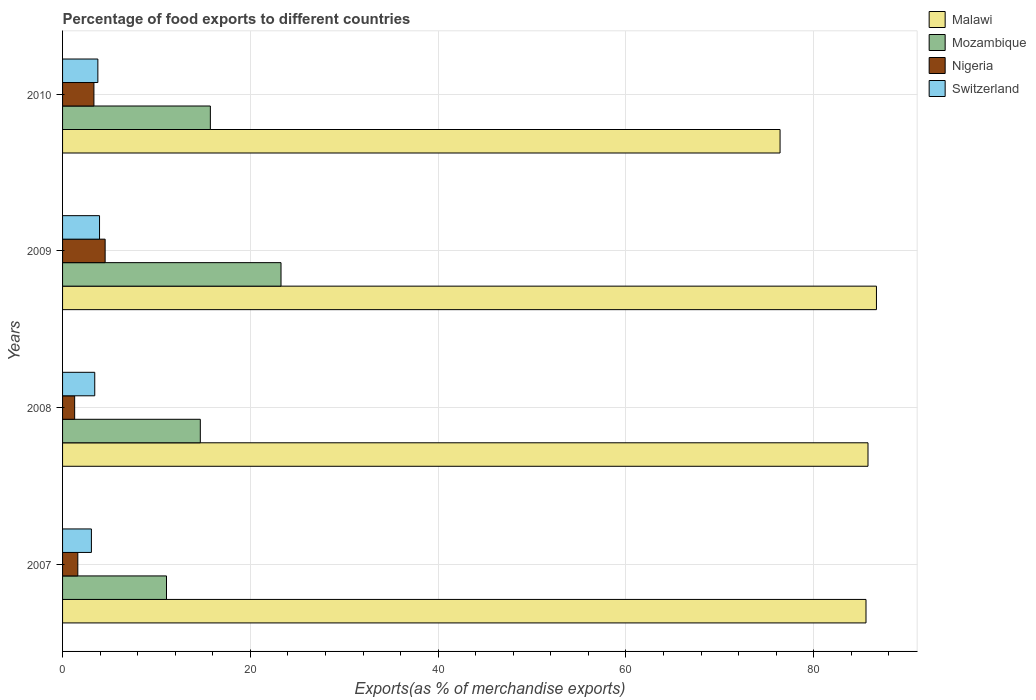Are the number of bars on each tick of the Y-axis equal?
Your answer should be compact. Yes. What is the label of the 1st group of bars from the top?
Provide a short and direct response. 2010. What is the percentage of exports to different countries in Nigeria in 2007?
Offer a very short reply. 1.62. Across all years, what is the maximum percentage of exports to different countries in Nigeria?
Give a very brief answer. 4.53. Across all years, what is the minimum percentage of exports to different countries in Switzerland?
Offer a very short reply. 3.07. In which year was the percentage of exports to different countries in Switzerland maximum?
Make the answer very short. 2009. In which year was the percentage of exports to different countries in Mozambique minimum?
Your answer should be compact. 2007. What is the total percentage of exports to different countries in Nigeria in the graph?
Keep it short and to the point. 10.78. What is the difference between the percentage of exports to different countries in Switzerland in 2009 and that in 2010?
Keep it short and to the point. 0.18. What is the difference between the percentage of exports to different countries in Nigeria in 2009 and the percentage of exports to different countries in Switzerland in 2008?
Your answer should be very brief. 1.11. What is the average percentage of exports to different countries in Switzerland per year?
Offer a terse response. 3.55. In the year 2007, what is the difference between the percentage of exports to different countries in Mozambique and percentage of exports to different countries in Malawi?
Your answer should be compact. -74.5. What is the ratio of the percentage of exports to different countries in Malawi in 2007 to that in 2008?
Your response must be concise. 1. What is the difference between the highest and the second highest percentage of exports to different countries in Switzerland?
Offer a very short reply. 0.18. What is the difference between the highest and the lowest percentage of exports to different countries in Nigeria?
Keep it short and to the point. 3.25. What does the 2nd bar from the top in 2008 represents?
Provide a short and direct response. Nigeria. What does the 3rd bar from the bottom in 2010 represents?
Give a very brief answer. Nigeria. Is it the case that in every year, the sum of the percentage of exports to different countries in Mozambique and percentage of exports to different countries in Nigeria is greater than the percentage of exports to different countries in Malawi?
Ensure brevity in your answer.  No. What is the difference between two consecutive major ticks on the X-axis?
Ensure brevity in your answer.  20. Does the graph contain grids?
Your answer should be very brief. Yes. Where does the legend appear in the graph?
Provide a short and direct response. Top right. What is the title of the graph?
Ensure brevity in your answer.  Percentage of food exports to different countries. What is the label or title of the X-axis?
Ensure brevity in your answer.  Exports(as % of merchandise exports). What is the label or title of the Y-axis?
Your response must be concise. Years. What is the Exports(as % of merchandise exports) of Malawi in 2007?
Provide a succinct answer. 85.57. What is the Exports(as % of merchandise exports) of Mozambique in 2007?
Offer a very short reply. 11.07. What is the Exports(as % of merchandise exports) in Nigeria in 2007?
Your response must be concise. 1.62. What is the Exports(as % of merchandise exports) of Switzerland in 2007?
Provide a short and direct response. 3.07. What is the Exports(as % of merchandise exports) in Malawi in 2008?
Your response must be concise. 85.79. What is the Exports(as % of merchandise exports) in Mozambique in 2008?
Provide a short and direct response. 14.67. What is the Exports(as % of merchandise exports) in Nigeria in 2008?
Ensure brevity in your answer.  1.29. What is the Exports(as % of merchandise exports) of Switzerland in 2008?
Your response must be concise. 3.43. What is the Exports(as % of merchandise exports) of Malawi in 2009?
Ensure brevity in your answer.  86.69. What is the Exports(as % of merchandise exports) of Mozambique in 2009?
Your answer should be very brief. 23.27. What is the Exports(as % of merchandise exports) in Nigeria in 2009?
Your answer should be very brief. 4.53. What is the Exports(as % of merchandise exports) of Switzerland in 2009?
Your answer should be very brief. 3.94. What is the Exports(as % of merchandise exports) of Malawi in 2010?
Keep it short and to the point. 76.42. What is the Exports(as % of merchandise exports) in Mozambique in 2010?
Keep it short and to the point. 15.74. What is the Exports(as % of merchandise exports) of Nigeria in 2010?
Offer a very short reply. 3.34. What is the Exports(as % of merchandise exports) in Switzerland in 2010?
Your response must be concise. 3.76. Across all years, what is the maximum Exports(as % of merchandise exports) of Malawi?
Keep it short and to the point. 86.69. Across all years, what is the maximum Exports(as % of merchandise exports) in Mozambique?
Provide a short and direct response. 23.27. Across all years, what is the maximum Exports(as % of merchandise exports) in Nigeria?
Your response must be concise. 4.53. Across all years, what is the maximum Exports(as % of merchandise exports) in Switzerland?
Offer a very short reply. 3.94. Across all years, what is the minimum Exports(as % of merchandise exports) in Malawi?
Make the answer very short. 76.42. Across all years, what is the minimum Exports(as % of merchandise exports) in Mozambique?
Keep it short and to the point. 11.07. Across all years, what is the minimum Exports(as % of merchandise exports) of Nigeria?
Offer a very short reply. 1.29. Across all years, what is the minimum Exports(as % of merchandise exports) in Switzerland?
Ensure brevity in your answer.  3.07. What is the total Exports(as % of merchandise exports) in Malawi in the graph?
Your answer should be compact. 334.46. What is the total Exports(as % of merchandise exports) of Mozambique in the graph?
Your answer should be very brief. 64.75. What is the total Exports(as % of merchandise exports) of Nigeria in the graph?
Ensure brevity in your answer.  10.78. What is the total Exports(as % of merchandise exports) in Switzerland in the graph?
Your answer should be compact. 14.19. What is the difference between the Exports(as % of merchandise exports) in Malawi in 2007 and that in 2008?
Offer a terse response. -0.21. What is the difference between the Exports(as % of merchandise exports) of Mozambique in 2007 and that in 2008?
Offer a terse response. -3.6. What is the difference between the Exports(as % of merchandise exports) in Nigeria in 2007 and that in 2008?
Offer a very short reply. 0.34. What is the difference between the Exports(as % of merchandise exports) of Switzerland in 2007 and that in 2008?
Keep it short and to the point. -0.36. What is the difference between the Exports(as % of merchandise exports) in Malawi in 2007 and that in 2009?
Provide a succinct answer. -1.11. What is the difference between the Exports(as % of merchandise exports) of Mozambique in 2007 and that in 2009?
Ensure brevity in your answer.  -12.2. What is the difference between the Exports(as % of merchandise exports) in Nigeria in 2007 and that in 2009?
Make the answer very short. -2.91. What is the difference between the Exports(as % of merchandise exports) in Switzerland in 2007 and that in 2009?
Give a very brief answer. -0.87. What is the difference between the Exports(as % of merchandise exports) of Malawi in 2007 and that in 2010?
Your answer should be compact. 9.15. What is the difference between the Exports(as % of merchandise exports) of Mozambique in 2007 and that in 2010?
Your answer should be compact. -4.67. What is the difference between the Exports(as % of merchandise exports) in Nigeria in 2007 and that in 2010?
Ensure brevity in your answer.  -1.72. What is the difference between the Exports(as % of merchandise exports) in Switzerland in 2007 and that in 2010?
Offer a terse response. -0.69. What is the difference between the Exports(as % of merchandise exports) in Malawi in 2008 and that in 2009?
Ensure brevity in your answer.  -0.9. What is the difference between the Exports(as % of merchandise exports) in Mozambique in 2008 and that in 2009?
Ensure brevity in your answer.  -8.6. What is the difference between the Exports(as % of merchandise exports) of Nigeria in 2008 and that in 2009?
Make the answer very short. -3.25. What is the difference between the Exports(as % of merchandise exports) of Switzerland in 2008 and that in 2009?
Offer a very short reply. -0.51. What is the difference between the Exports(as % of merchandise exports) in Malawi in 2008 and that in 2010?
Your response must be concise. 9.37. What is the difference between the Exports(as % of merchandise exports) of Mozambique in 2008 and that in 2010?
Your answer should be compact. -1.07. What is the difference between the Exports(as % of merchandise exports) of Nigeria in 2008 and that in 2010?
Provide a short and direct response. -2.05. What is the difference between the Exports(as % of merchandise exports) of Switzerland in 2008 and that in 2010?
Your answer should be compact. -0.33. What is the difference between the Exports(as % of merchandise exports) of Malawi in 2009 and that in 2010?
Your answer should be compact. 10.27. What is the difference between the Exports(as % of merchandise exports) of Mozambique in 2009 and that in 2010?
Ensure brevity in your answer.  7.53. What is the difference between the Exports(as % of merchandise exports) of Nigeria in 2009 and that in 2010?
Offer a terse response. 1.19. What is the difference between the Exports(as % of merchandise exports) of Switzerland in 2009 and that in 2010?
Offer a very short reply. 0.18. What is the difference between the Exports(as % of merchandise exports) of Malawi in 2007 and the Exports(as % of merchandise exports) of Mozambique in 2008?
Your answer should be compact. 70.9. What is the difference between the Exports(as % of merchandise exports) of Malawi in 2007 and the Exports(as % of merchandise exports) of Nigeria in 2008?
Keep it short and to the point. 84.28. What is the difference between the Exports(as % of merchandise exports) in Malawi in 2007 and the Exports(as % of merchandise exports) in Switzerland in 2008?
Give a very brief answer. 82.14. What is the difference between the Exports(as % of merchandise exports) in Mozambique in 2007 and the Exports(as % of merchandise exports) in Nigeria in 2008?
Keep it short and to the point. 9.78. What is the difference between the Exports(as % of merchandise exports) in Mozambique in 2007 and the Exports(as % of merchandise exports) in Switzerland in 2008?
Your answer should be compact. 7.64. What is the difference between the Exports(as % of merchandise exports) of Nigeria in 2007 and the Exports(as % of merchandise exports) of Switzerland in 2008?
Keep it short and to the point. -1.8. What is the difference between the Exports(as % of merchandise exports) in Malawi in 2007 and the Exports(as % of merchandise exports) in Mozambique in 2009?
Ensure brevity in your answer.  62.31. What is the difference between the Exports(as % of merchandise exports) of Malawi in 2007 and the Exports(as % of merchandise exports) of Nigeria in 2009?
Give a very brief answer. 81.04. What is the difference between the Exports(as % of merchandise exports) of Malawi in 2007 and the Exports(as % of merchandise exports) of Switzerland in 2009?
Your response must be concise. 81.63. What is the difference between the Exports(as % of merchandise exports) of Mozambique in 2007 and the Exports(as % of merchandise exports) of Nigeria in 2009?
Ensure brevity in your answer.  6.54. What is the difference between the Exports(as % of merchandise exports) in Mozambique in 2007 and the Exports(as % of merchandise exports) in Switzerland in 2009?
Provide a short and direct response. 7.13. What is the difference between the Exports(as % of merchandise exports) of Nigeria in 2007 and the Exports(as % of merchandise exports) of Switzerland in 2009?
Provide a short and direct response. -2.31. What is the difference between the Exports(as % of merchandise exports) of Malawi in 2007 and the Exports(as % of merchandise exports) of Mozambique in 2010?
Your answer should be compact. 69.83. What is the difference between the Exports(as % of merchandise exports) in Malawi in 2007 and the Exports(as % of merchandise exports) in Nigeria in 2010?
Ensure brevity in your answer.  82.23. What is the difference between the Exports(as % of merchandise exports) of Malawi in 2007 and the Exports(as % of merchandise exports) of Switzerland in 2010?
Give a very brief answer. 81.81. What is the difference between the Exports(as % of merchandise exports) in Mozambique in 2007 and the Exports(as % of merchandise exports) in Nigeria in 2010?
Make the answer very short. 7.73. What is the difference between the Exports(as % of merchandise exports) in Mozambique in 2007 and the Exports(as % of merchandise exports) in Switzerland in 2010?
Offer a very short reply. 7.31. What is the difference between the Exports(as % of merchandise exports) in Nigeria in 2007 and the Exports(as % of merchandise exports) in Switzerland in 2010?
Your answer should be very brief. -2.14. What is the difference between the Exports(as % of merchandise exports) of Malawi in 2008 and the Exports(as % of merchandise exports) of Mozambique in 2009?
Keep it short and to the point. 62.52. What is the difference between the Exports(as % of merchandise exports) of Malawi in 2008 and the Exports(as % of merchandise exports) of Nigeria in 2009?
Ensure brevity in your answer.  81.25. What is the difference between the Exports(as % of merchandise exports) in Malawi in 2008 and the Exports(as % of merchandise exports) in Switzerland in 2009?
Your answer should be very brief. 81.85. What is the difference between the Exports(as % of merchandise exports) of Mozambique in 2008 and the Exports(as % of merchandise exports) of Nigeria in 2009?
Keep it short and to the point. 10.14. What is the difference between the Exports(as % of merchandise exports) in Mozambique in 2008 and the Exports(as % of merchandise exports) in Switzerland in 2009?
Provide a succinct answer. 10.73. What is the difference between the Exports(as % of merchandise exports) in Nigeria in 2008 and the Exports(as % of merchandise exports) in Switzerland in 2009?
Offer a terse response. -2.65. What is the difference between the Exports(as % of merchandise exports) of Malawi in 2008 and the Exports(as % of merchandise exports) of Mozambique in 2010?
Give a very brief answer. 70.04. What is the difference between the Exports(as % of merchandise exports) of Malawi in 2008 and the Exports(as % of merchandise exports) of Nigeria in 2010?
Make the answer very short. 82.45. What is the difference between the Exports(as % of merchandise exports) in Malawi in 2008 and the Exports(as % of merchandise exports) in Switzerland in 2010?
Offer a very short reply. 82.03. What is the difference between the Exports(as % of merchandise exports) of Mozambique in 2008 and the Exports(as % of merchandise exports) of Nigeria in 2010?
Give a very brief answer. 11.33. What is the difference between the Exports(as % of merchandise exports) of Mozambique in 2008 and the Exports(as % of merchandise exports) of Switzerland in 2010?
Make the answer very short. 10.91. What is the difference between the Exports(as % of merchandise exports) of Nigeria in 2008 and the Exports(as % of merchandise exports) of Switzerland in 2010?
Ensure brevity in your answer.  -2.47. What is the difference between the Exports(as % of merchandise exports) in Malawi in 2009 and the Exports(as % of merchandise exports) in Mozambique in 2010?
Keep it short and to the point. 70.94. What is the difference between the Exports(as % of merchandise exports) in Malawi in 2009 and the Exports(as % of merchandise exports) in Nigeria in 2010?
Give a very brief answer. 83.35. What is the difference between the Exports(as % of merchandise exports) in Malawi in 2009 and the Exports(as % of merchandise exports) in Switzerland in 2010?
Provide a short and direct response. 82.93. What is the difference between the Exports(as % of merchandise exports) in Mozambique in 2009 and the Exports(as % of merchandise exports) in Nigeria in 2010?
Your answer should be very brief. 19.93. What is the difference between the Exports(as % of merchandise exports) in Mozambique in 2009 and the Exports(as % of merchandise exports) in Switzerland in 2010?
Ensure brevity in your answer.  19.51. What is the difference between the Exports(as % of merchandise exports) in Nigeria in 2009 and the Exports(as % of merchandise exports) in Switzerland in 2010?
Keep it short and to the point. 0.78. What is the average Exports(as % of merchandise exports) in Malawi per year?
Your answer should be very brief. 83.62. What is the average Exports(as % of merchandise exports) in Mozambique per year?
Offer a very short reply. 16.19. What is the average Exports(as % of merchandise exports) in Nigeria per year?
Provide a succinct answer. 2.7. What is the average Exports(as % of merchandise exports) in Switzerland per year?
Make the answer very short. 3.55. In the year 2007, what is the difference between the Exports(as % of merchandise exports) in Malawi and Exports(as % of merchandise exports) in Mozambique?
Provide a short and direct response. 74.5. In the year 2007, what is the difference between the Exports(as % of merchandise exports) in Malawi and Exports(as % of merchandise exports) in Nigeria?
Ensure brevity in your answer.  83.95. In the year 2007, what is the difference between the Exports(as % of merchandise exports) in Malawi and Exports(as % of merchandise exports) in Switzerland?
Your answer should be compact. 82.5. In the year 2007, what is the difference between the Exports(as % of merchandise exports) of Mozambique and Exports(as % of merchandise exports) of Nigeria?
Ensure brevity in your answer.  9.45. In the year 2007, what is the difference between the Exports(as % of merchandise exports) in Mozambique and Exports(as % of merchandise exports) in Switzerland?
Your answer should be compact. 8. In the year 2007, what is the difference between the Exports(as % of merchandise exports) of Nigeria and Exports(as % of merchandise exports) of Switzerland?
Your answer should be compact. -1.45. In the year 2008, what is the difference between the Exports(as % of merchandise exports) in Malawi and Exports(as % of merchandise exports) in Mozambique?
Ensure brevity in your answer.  71.12. In the year 2008, what is the difference between the Exports(as % of merchandise exports) in Malawi and Exports(as % of merchandise exports) in Nigeria?
Give a very brief answer. 84.5. In the year 2008, what is the difference between the Exports(as % of merchandise exports) of Malawi and Exports(as % of merchandise exports) of Switzerland?
Make the answer very short. 82.36. In the year 2008, what is the difference between the Exports(as % of merchandise exports) in Mozambique and Exports(as % of merchandise exports) in Nigeria?
Offer a terse response. 13.38. In the year 2008, what is the difference between the Exports(as % of merchandise exports) in Mozambique and Exports(as % of merchandise exports) in Switzerland?
Offer a terse response. 11.24. In the year 2008, what is the difference between the Exports(as % of merchandise exports) of Nigeria and Exports(as % of merchandise exports) of Switzerland?
Your response must be concise. -2.14. In the year 2009, what is the difference between the Exports(as % of merchandise exports) of Malawi and Exports(as % of merchandise exports) of Mozambique?
Ensure brevity in your answer.  63.42. In the year 2009, what is the difference between the Exports(as % of merchandise exports) in Malawi and Exports(as % of merchandise exports) in Nigeria?
Provide a short and direct response. 82.15. In the year 2009, what is the difference between the Exports(as % of merchandise exports) in Malawi and Exports(as % of merchandise exports) in Switzerland?
Provide a succinct answer. 82.75. In the year 2009, what is the difference between the Exports(as % of merchandise exports) in Mozambique and Exports(as % of merchandise exports) in Nigeria?
Ensure brevity in your answer.  18.73. In the year 2009, what is the difference between the Exports(as % of merchandise exports) in Mozambique and Exports(as % of merchandise exports) in Switzerland?
Offer a very short reply. 19.33. In the year 2009, what is the difference between the Exports(as % of merchandise exports) of Nigeria and Exports(as % of merchandise exports) of Switzerland?
Keep it short and to the point. 0.6. In the year 2010, what is the difference between the Exports(as % of merchandise exports) in Malawi and Exports(as % of merchandise exports) in Mozambique?
Keep it short and to the point. 60.68. In the year 2010, what is the difference between the Exports(as % of merchandise exports) in Malawi and Exports(as % of merchandise exports) in Nigeria?
Make the answer very short. 73.08. In the year 2010, what is the difference between the Exports(as % of merchandise exports) in Malawi and Exports(as % of merchandise exports) in Switzerland?
Your answer should be compact. 72.66. In the year 2010, what is the difference between the Exports(as % of merchandise exports) in Mozambique and Exports(as % of merchandise exports) in Nigeria?
Provide a succinct answer. 12.4. In the year 2010, what is the difference between the Exports(as % of merchandise exports) of Mozambique and Exports(as % of merchandise exports) of Switzerland?
Ensure brevity in your answer.  11.98. In the year 2010, what is the difference between the Exports(as % of merchandise exports) of Nigeria and Exports(as % of merchandise exports) of Switzerland?
Your answer should be very brief. -0.42. What is the ratio of the Exports(as % of merchandise exports) in Mozambique in 2007 to that in 2008?
Your response must be concise. 0.75. What is the ratio of the Exports(as % of merchandise exports) of Nigeria in 2007 to that in 2008?
Your answer should be very brief. 1.26. What is the ratio of the Exports(as % of merchandise exports) in Switzerland in 2007 to that in 2008?
Give a very brief answer. 0.9. What is the ratio of the Exports(as % of merchandise exports) of Malawi in 2007 to that in 2009?
Keep it short and to the point. 0.99. What is the ratio of the Exports(as % of merchandise exports) in Mozambique in 2007 to that in 2009?
Keep it short and to the point. 0.48. What is the ratio of the Exports(as % of merchandise exports) of Nigeria in 2007 to that in 2009?
Make the answer very short. 0.36. What is the ratio of the Exports(as % of merchandise exports) of Switzerland in 2007 to that in 2009?
Provide a succinct answer. 0.78. What is the ratio of the Exports(as % of merchandise exports) of Malawi in 2007 to that in 2010?
Offer a very short reply. 1.12. What is the ratio of the Exports(as % of merchandise exports) in Mozambique in 2007 to that in 2010?
Give a very brief answer. 0.7. What is the ratio of the Exports(as % of merchandise exports) in Nigeria in 2007 to that in 2010?
Offer a very short reply. 0.49. What is the ratio of the Exports(as % of merchandise exports) in Switzerland in 2007 to that in 2010?
Give a very brief answer. 0.82. What is the ratio of the Exports(as % of merchandise exports) in Malawi in 2008 to that in 2009?
Offer a very short reply. 0.99. What is the ratio of the Exports(as % of merchandise exports) in Mozambique in 2008 to that in 2009?
Provide a short and direct response. 0.63. What is the ratio of the Exports(as % of merchandise exports) of Nigeria in 2008 to that in 2009?
Your response must be concise. 0.28. What is the ratio of the Exports(as % of merchandise exports) in Switzerland in 2008 to that in 2009?
Provide a succinct answer. 0.87. What is the ratio of the Exports(as % of merchandise exports) in Malawi in 2008 to that in 2010?
Ensure brevity in your answer.  1.12. What is the ratio of the Exports(as % of merchandise exports) in Mozambique in 2008 to that in 2010?
Provide a short and direct response. 0.93. What is the ratio of the Exports(as % of merchandise exports) of Nigeria in 2008 to that in 2010?
Offer a very short reply. 0.39. What is the ratio of the Exports(as % of merchandise exports) of Switzerland in 2008 to that in 2010?
Your answer should be compact. 0.91. What is the ratio of the Exports(as % of merchandise exports) of Malawi in 2009 to that in 2010?
Ensure brevity in your answer.  1.13. What is the ratio of the Exports(as % of merchandise exports) of Mozambique in 2009 to that in 2010?
Offer a terse response. 1.48. What is the ratio of the Exports(as % of merchandise exports) in Nigeria in 2009 to that in 2010?
Your answer should be compact. 1.36. What is the ratio of the Exports(as % of merchandise exports) of Switzerland in 2009 to that in 2010?
Give a very brief answer. 1.05. What is the difference between the highest and the second highest Exports(as % of merchandise exports) in Malawi?
Provide a succinct answer. 0.9. What is the difference between the highest and the second highest Exports(as % of merchandise exports) in Mozambique?
Make the answer very short. 7.53. What is the difference between the highest and the second highest Exports(as % of merchandise exports) in Nigeria?
Offer a terse response. 1.19. What is the difference between the highest and the second highest Exports(as % of merchandise exports) of Switzerland?
Offer a very short reply. 0.18. What is the difference between the highest and the lowest Exports(as % of merchandise exports) of Malawi?
Make the answer very short. 10.27. What is the difference between the highest and the lowest Exports(as % of merchandise exports) of Mozambique?
Offer a terse response. 12.2. What is the difference between the highest and the lowest Exports(as % of merchandise exports) in Nigeria?
Your answer should be compact. 3.25. What is the difference between the highest and the lowest Exports(as % of merchandise exports) in Switzerland?
Make the answer very short. 0.87. 